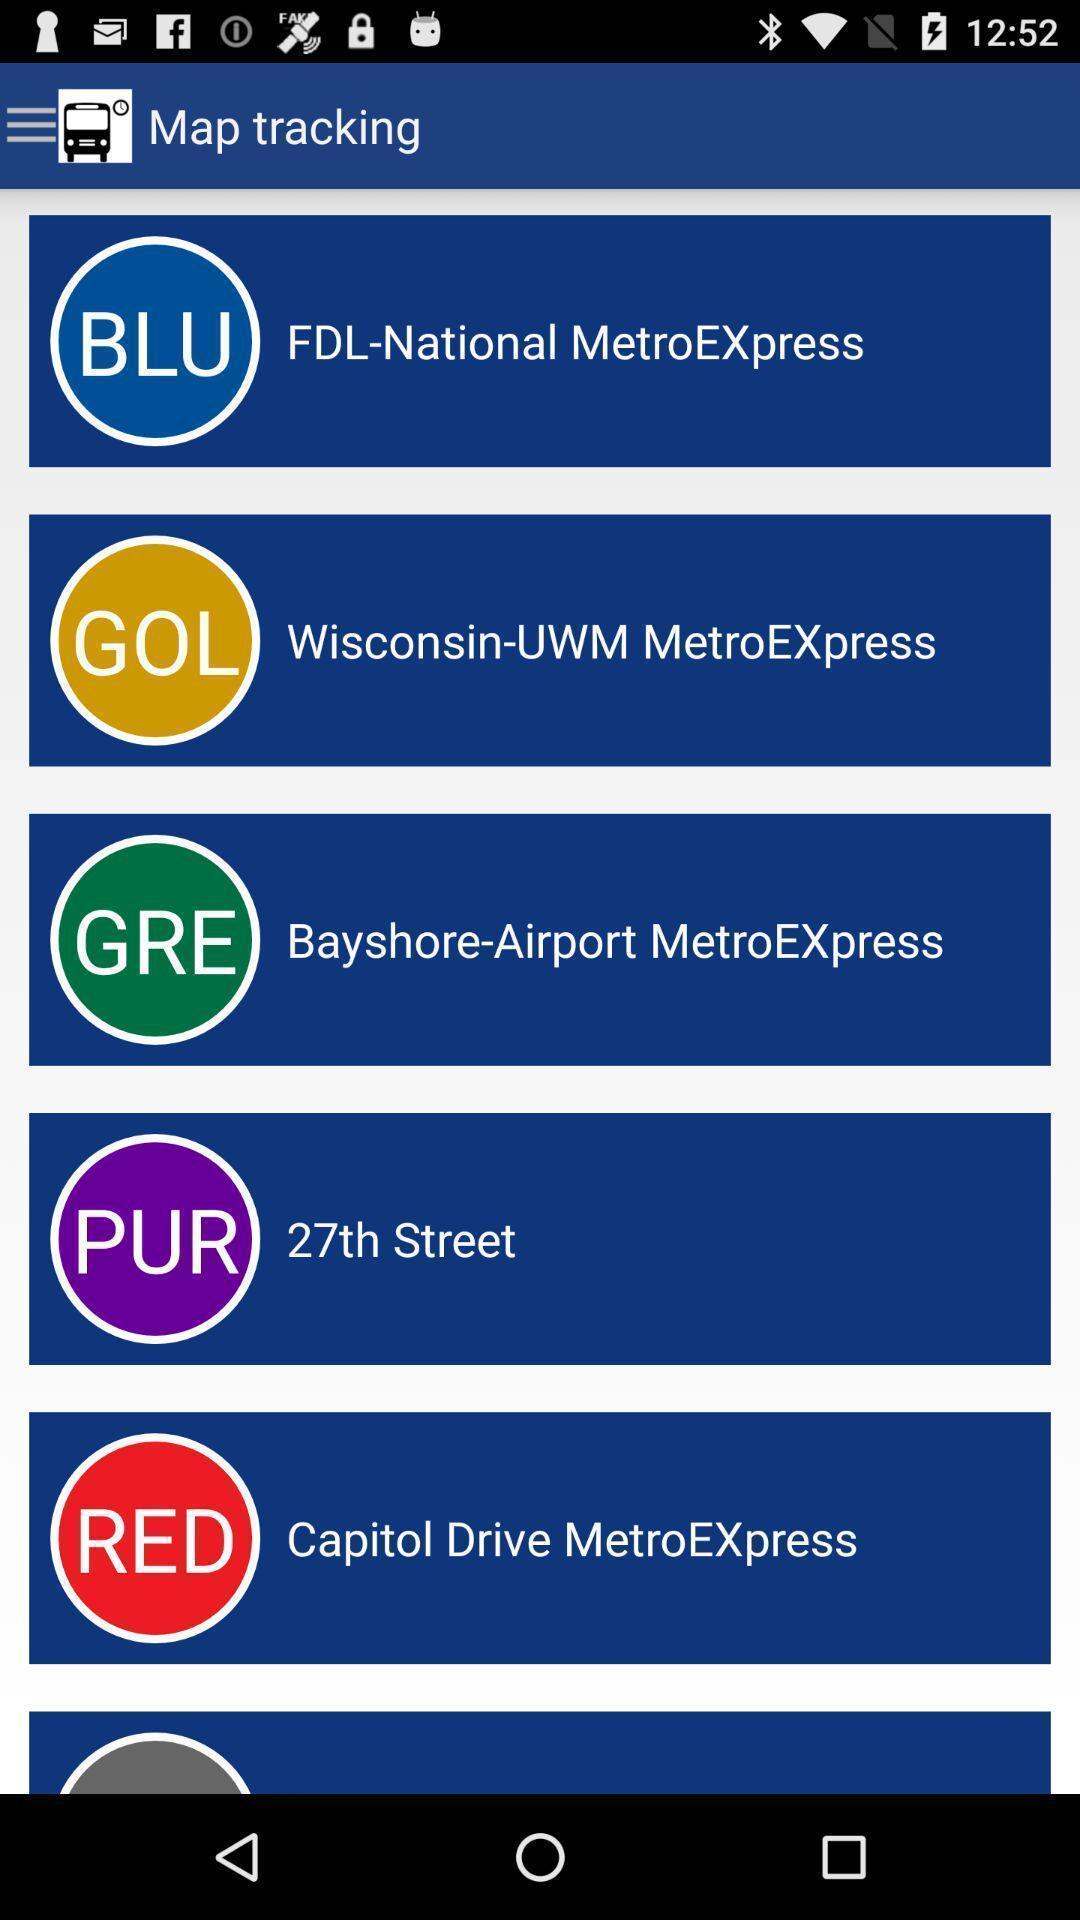Give me a narrative description of this picture. Screen shows map tracking options. 